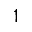<formula> <loc_0><loc_0><loc_500><loc_500>1</formula> 